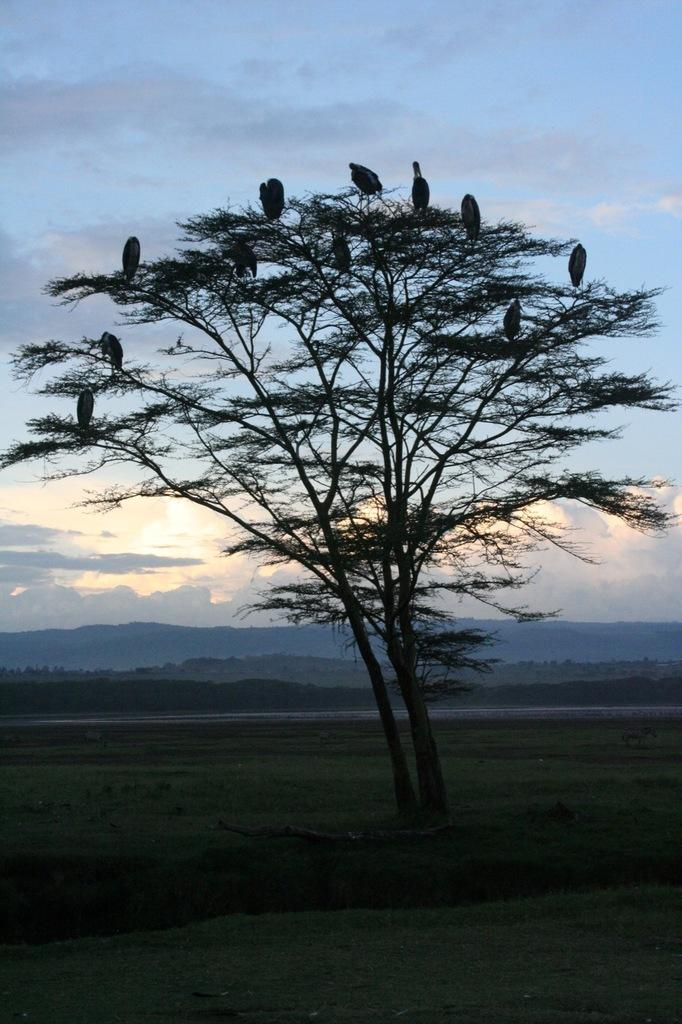What type of vegetation is present in the image? There is grass in the image. What other natural elements can be seen in the image? There is a tree in the image. What animals are visible in the image? There are birds in the image. What can be seen in the distance in the image? There are hills visible in the background of the image. What is visible at the top of the image? The sky is visible at the top of the image. What type of oatmeal is being served in the image? There is no oatmeal present in the image; it features grass, a tree, birds, hills, and the sky. Can you identify the actor in the image? There is no actor present in the image; it is a natural scene with no human subjects. 